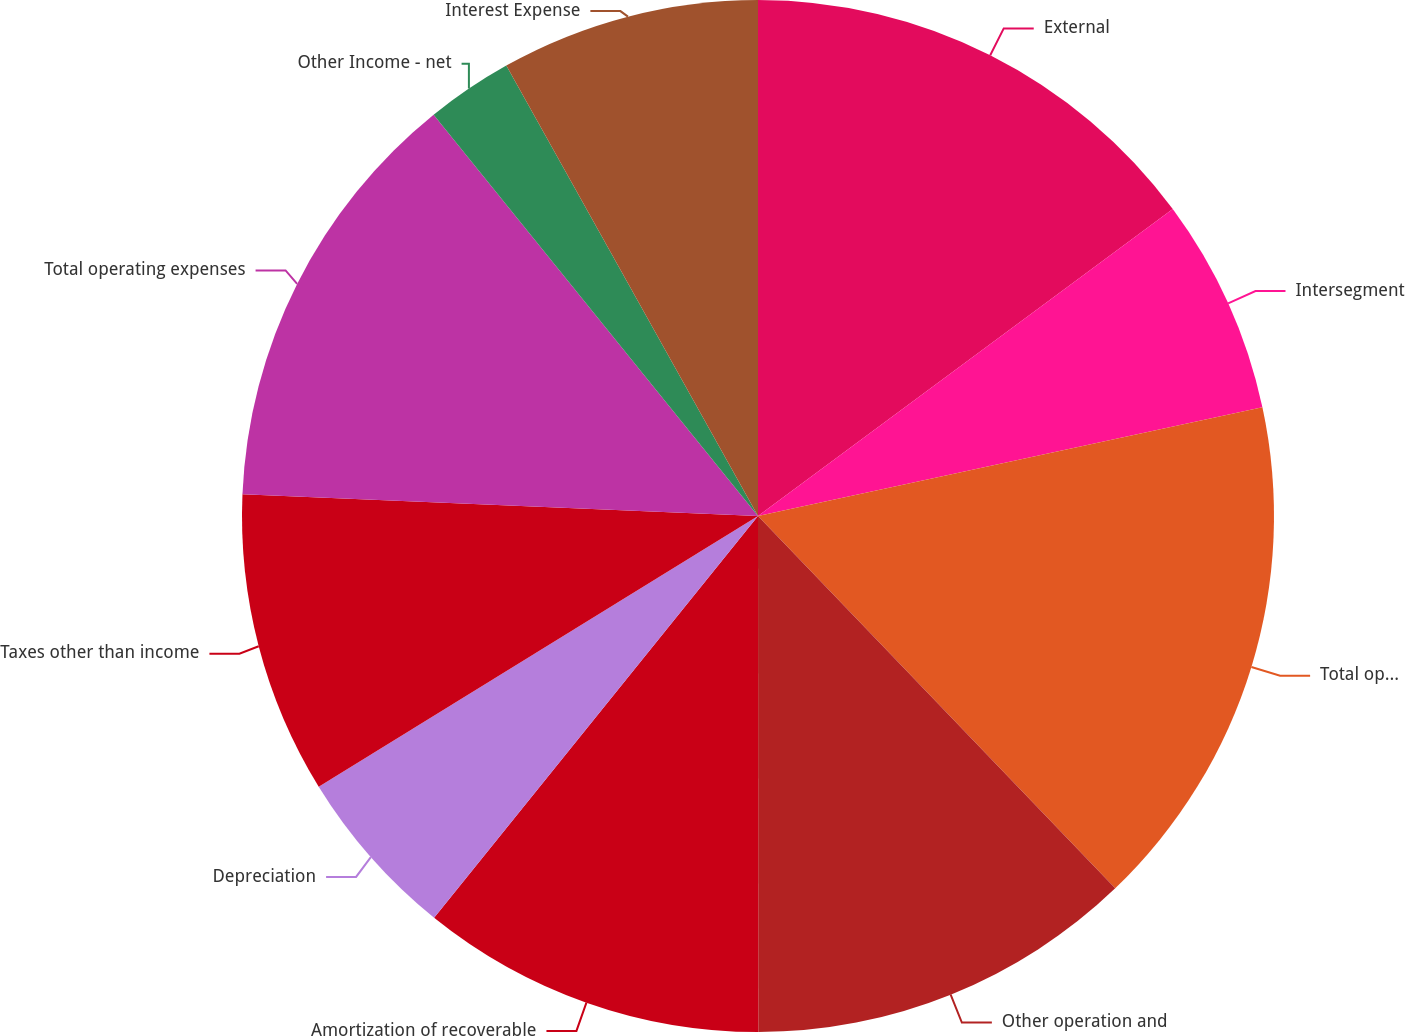Convert chart to OTSL. <chart><loc_0><loc_0><loc_500><loc_500><pie_chart><fcel>External<fcel>Intersegment<fcel>Total operating revenues<fcel>Other operation and<fcel>Amortization of recoverable<fcel>Depreciation<fcel>Taxes other than income<fcel>Total operating expenses<fcel>Other Income - net<fcel>Interest Expense<nl><fcel>14.86%<fcel>6.76%<fcel>16.21%<fcel>12.16%<fcel>10.81%<fcel>5.41%<fcel>9.46%<fcel>13.51%<fcel>2.71%<fcel>8.11%<nl></chart> 